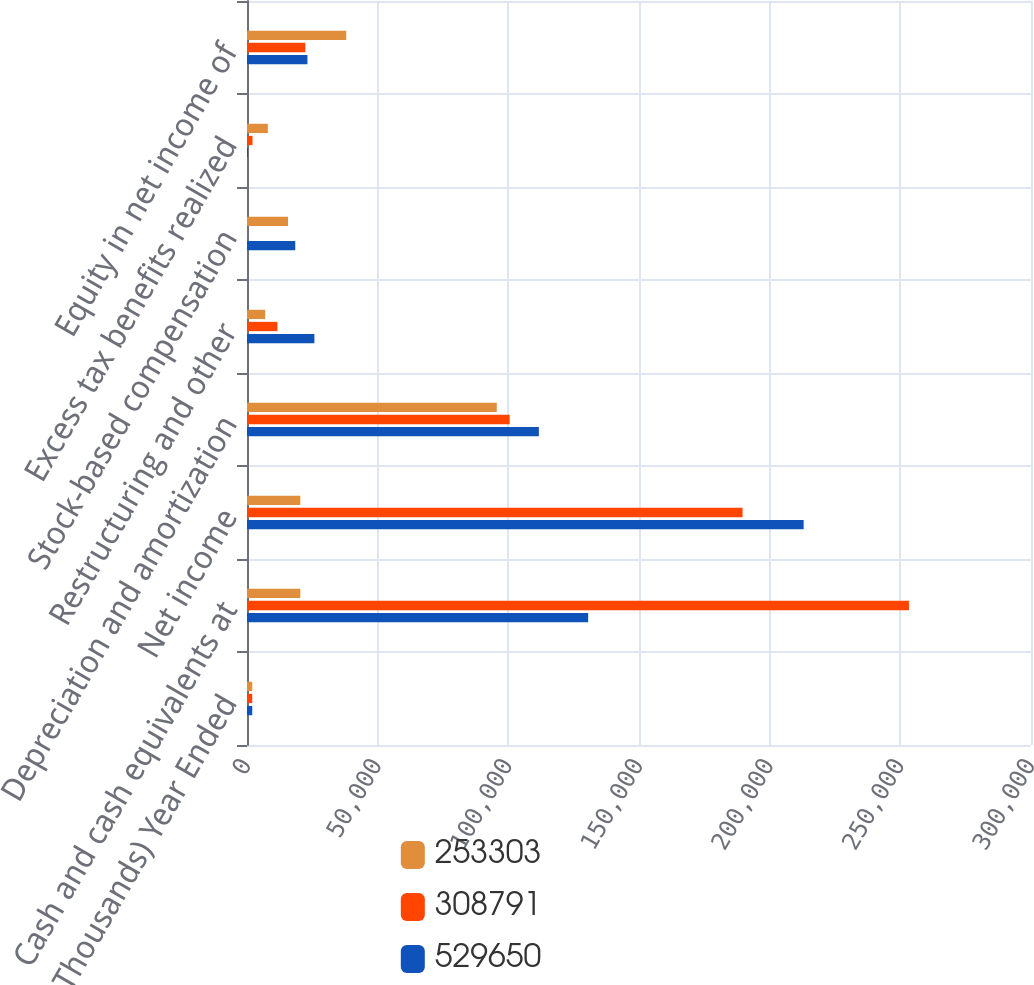Convert chart. <chart><loc_0><loc_0><loc_500><loc_500><stacked_bar_chart><ecel><fcel>(In Thousands) Year Ended<fcel>Cash and cash equivalents at<fcel>Net income<fcel>Depreciation and amortization<fcel>Restructuring and other<fcel>Stock-based compensation<fcel>Excess tax benefits realized<fcel>Equity in net income of<nl><fcel>253303<fcel>2010<fcel>20394.5<fcel>20394.5<fcel>95578<fcel>6958<fcel>15694<fcel>7981<fcel>37975<nl><fcel>308791<fcel>2009<fcel>253303<fcel>189623<fcel>100513<fcel>11643<fcel>307<fcel>2111<fcel>22322<nl><fcel>529650<fcel>2008<fcel>130551<fcel>213008<fcel>111685<fcel>25789<fcel>18467<fcel>372<fcel>23126<nl></chart> 